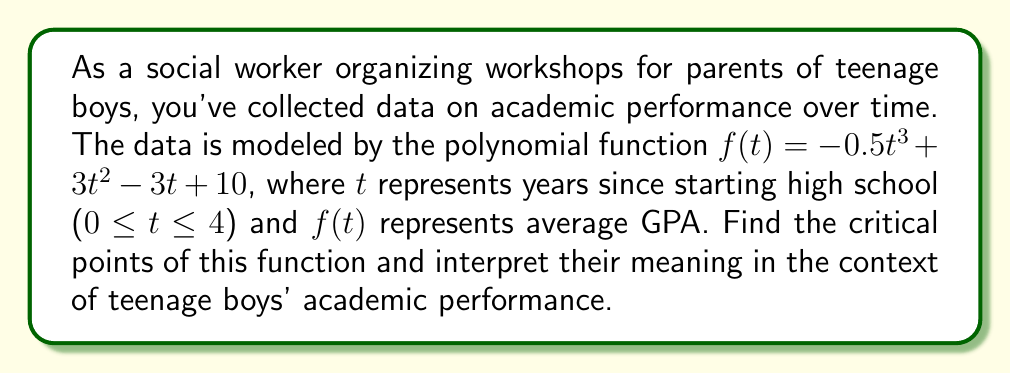What is the answer to this math problem? To find the critical points, we need to follow these steps:

1) Find the derivative of the function:
   $f'(t) = -1.5t^2 + 6t - 3$

2) Set the derivative equal to zero and solve for t:
   $-1.5t^2 + 6t - 3 = 0$

3) This is a quadratic equation. We can solve it using the quadratic formula:
   $t = \frac{-b \pm \sqrt{b^2 - 4ac}}{2a}$

   Where $a = -1.5$, $b = 6$, and $c = -3$

4) Plugging in these values:
   $t = \frac{-6 \pm \sqrt{36 - 4(-1.5)(-3)}}{2(-1.5)}$
   $= \frac{-6 \pm \sqrt{36 - 18}}{-3}$
   $= \frac{-6 \pm \sqrt{18}}{-3}$
   $= \frac{-6 \pm 3\sqrt{2}}{-3}$

5) Simplifying:
   $t = 2 \pm \frac{\sqrt{2}}{2}$

6) This gives us two critical points:
   $t_1 = 2 + \frac{\sqrt{2}}{2} \approx 2.71$ years
   $t_2 = 2 - \frac{\sqrt{2}}{2} \approx 1.29$ years

Interpretation: The critical points represent times when the rate of change in academic performance shifts. The first critical point (around 1.29 years into high school) might represent a transition period where initial challenges are overcome. The second critical point (around 2.71 years) could indicate a point where academic performance peaks before potentially declining in the final year.
Answer: Critical points: $t_1 = 2 + \frac{\sqrt{2}}{2}$, $t_2 = 2 - \frac{\sqrt{2}}{2}$ 